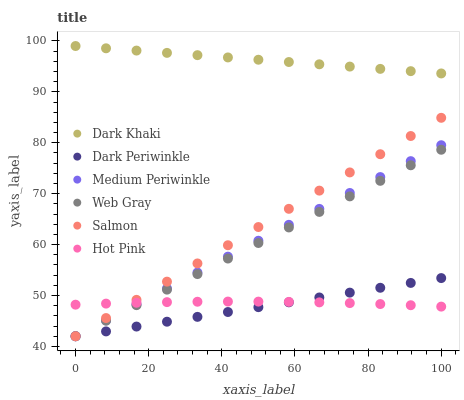Does Dark Periwinkle have the minimum area under the curve?
Answer yes or no. Yes. Does Dark Khaki have the maximum area under the curve?
Answer yes or no. Yes. Does Medium Periwinkle have the minimum area under the curve?
Answer yes or no. No. Does Medium Periwinkle have the maximum area under the curve?
Answer yes or no. No. Is Dark Periwinkle the smoothest?
Answer yes or no. Yes. Is Hot Pink the roughest?
Answer yes or no. Yes. Is Medium Periwinkle the smoothest?
Answer yes or no. No. Is Medium Periwinkle the roughest?
Answer yes or no. No. Does Web Gray have the lowest value?
Answer yes or no. Yes. Does Hot Pink have the lowest value?
Answer yes or no. No. Does Dark Khaki have the highest value?
Answer yes or no. Yes. Does Medium Periwinkle have the highest value?
Answer yes or no. No. Is Web Gray less than Dark Khaki?
Answer yes or no. Yes. Is Dark Khaki greater than Dark Periwinkle?
Answer yes or no. Yes. Does Dark Periwinkle intersect Web Gray?
Answer yes or no. Yes. Is Dark Periwinkle less than Web Gray?
Answer yes or no. No. Is Dark Periwinkle greater than Web Gray?
Answer yes or no. No. Does Web Gray intersect Dark Khaki?
Answer yes or no. No. 